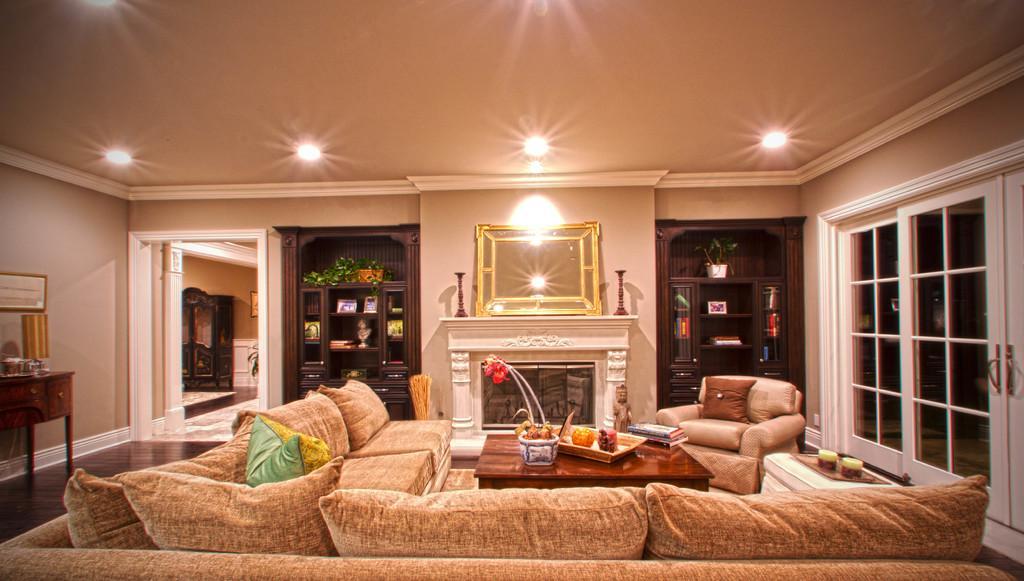Describe this image in one or two sentences. In this room there are sofa,table,water plant,cupboards,books,door,chair,books on the table. On the rooftop there are lights. On the right there is a table. 